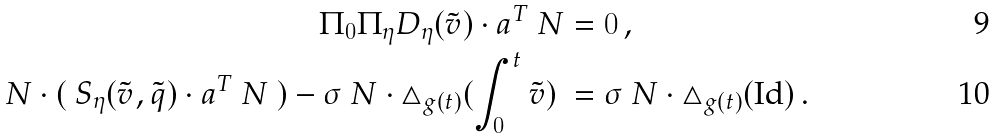Convert formula to latex. <formula><loc_0><loc_0><loc_500><loc_500>\Pi _ { 0 } \Pi _ { \eta } D _ { \eta } ( \tilde { v } ) \cdot a ^ { T } \ N & = 0 \, , \\ N \cdot ( \ S _ { \eta } ( \tilde { v } , \tilde { q } ) \cdot a ^ { T } \ N \ ) - \sigma \ N \cdot \triangle _ { g ( t ) } ( \int _ { 0 } ^ { t } { \tilde { v } } ) \ & = \sigma \ N \cdot \triangle _ { g ( t ) } ( \text {Id} ) \, .</formula> 